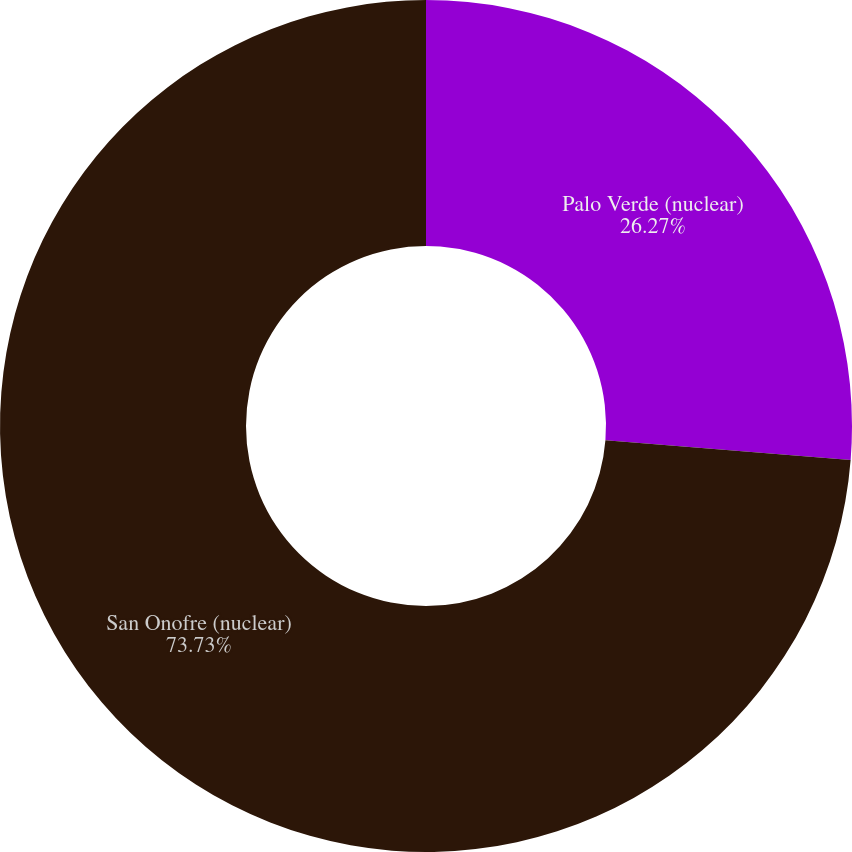<chart> <loc_0><loc_0><loc_500><loc_500><pie_chart><fcel>Palo Verde (nuclear)<fcel>San Onofre (nuclear)<nl><fcel>26.27%<fcel>73.73%<nl></chart> 